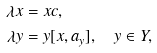Convert formula to latex. <formula><loc_0><loc_0><loc_500><loc_500>\lambda x & = x c , \\ \lambda y & = y [ x , a _ { y } ] , \quad y \in Y ,</formula> 